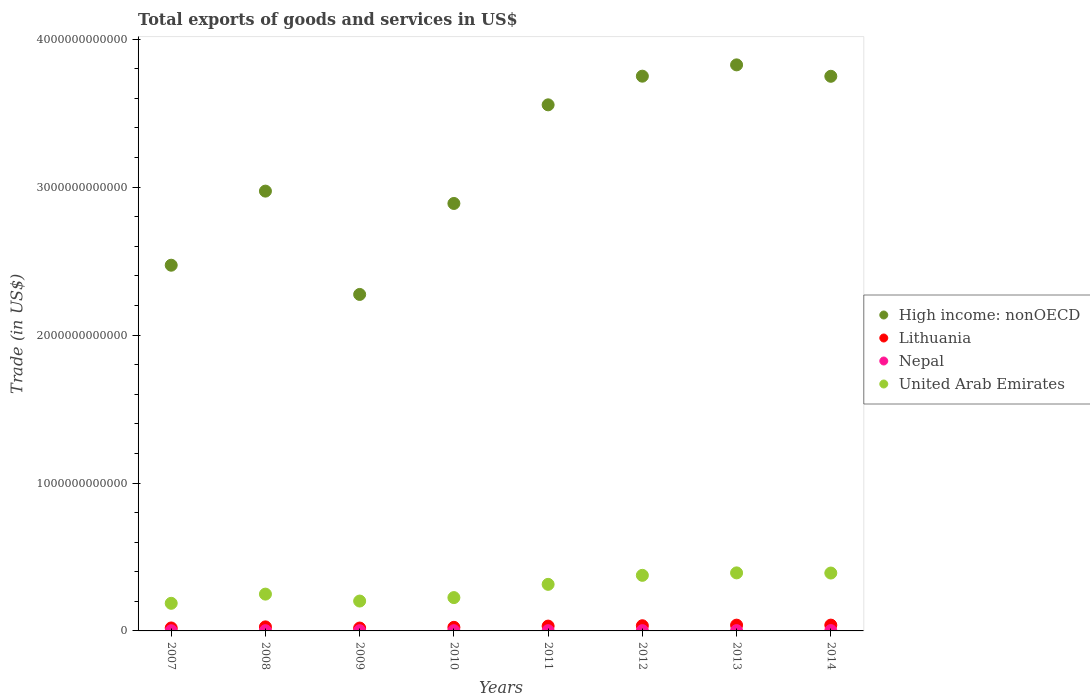How many different coloured dotlines are there?
Your answer should be compact. 4. Is the number of dotlines equal to the number of legend labels?
Your response must be concise. Yes. What is the total exports of goods and services in Lithuania in 2014?
Make the answer very short. 3.93e+1. Across all years, what is the maximum total exports of goods and services in Lithuania?
Make the answer very short. 3.93e+1. Across all years, what is the minimum total exports of goods and services in Nepal?
Offer a very short reply. 1.33e+09. In which year was the total exports of goods and services in Nepal maximum?
Offer a terse response. 2014. What is the total total exports of goods and services in Lithuania in the graph?
Ensure brevity in your answer.  2.37e+11. What is the difference between the total exports of goods and services in High income: nonOECD in 2007 and that in 2010?
Your answer should be very brief. -4.17e+11. What is the difference between the total exports of goods and services in United Arab Emirates in 2014 and the total exports of goods and services in Nepal in 2007?
Offer a terse response. 3.90e+11. What is the average total exports of goods and services in High income: nonOECD per year?
Give a very brief answer. 3.19e+12. In the year 2009, what is the difference between the total exports of goods and services in High income: nonOECD and total exports of goods and services in Nepal?
Provide a succinct answer. 2.27e+12. In how many years, is the total exports of goods and services in United Arab Emirates greater than 800000000000 US$?
Provide a short and direct response. 0. What is the ratio of the total exports of goods and services in Nepal in 2008 to that in 2009?
Your answer should be very brief. 1. What is the difference between the highest and the second highest total exports of goods and services in Lithuania?
Ensure brevity in your answer.  2.60e+08. What is the difference between the highest and the lowest total exports of goods and services in High income: nonOECD?
Offer a very short reply. 1.55e+12. In how many years, is the total exports of goods and services in Lithuania greater than the average total exports of goods and services in Lithuania taken over all years?
Give a very brief answer. 4. Is it the case that in every year, the sum of the total exports of goods and services in High income: nonOECD and total exports of goods and services in Lithuania  is greater than the sum of total exports of goods and services in Nepal and total exports of goods and services in United Arab Emirates?
Your answer should be very brief. Yes. Is it the case that in every year, the sum of the total exports of goods and services in Lithuania and total exports of goods and services in Nepal  is greater than the total exports of goods and services in High income: nonOECD?
Ensure brevity in your answer.  No. Is the total exports of goods and services in High income: nonOECD strictly less than the total exports of goods and services in United Arab Emirates over the years?
Your answer should be compact. No. How many dotlines are there?
Make the answer very short. 4. What is the difference between two consecutive major ticks on the Y-axis?
Provide a short and direct response. 1.00e+12. Does the graph contain grids?
Provide a succinct answer. No. Where does the legend appear in the graph?
Your answer should be very brief. Center right. What is the title of the graph?
Make the answer very short. Total exports of goods and services in US$. Does "Northern Mariana Islands" appear as one of the legend labels in the graph?
Your response must be concise. No. What is the label or title of the Y-axis?
Your answer should be compact. Trade (in US$). What is the Trade (in US$) in High income: nonOECD in 2007?
Ensure brevity in your answer.  2.47e+12. What is the Trade (in US$) of Lithuania in 2007?
Keep it short and to the point. 2.00e+1. What is the Trade (in US$) of Nepal in 2007?
Your response must be concise. 1.33e+09. What is the Trade (in US$) in United Arab Emirates in 2007?
Offer a very short reply. 1.87e+11. What is the Trade (in US$) in High income: nonOECD in 2008?
Ensure brevity in your answer.  2.97e+12. What is the Trade (in US$) of Lithuania in 2008?
Ensure brevity in your answer.  2.73e+1. What is the Trade (in US$) in Nepal in 2008?
Your answer should be very brief. 1.60e+09. What is the Trade (in US$) in United Arab Emirates in 2008?
Offer a terse response. 2.49e+11. What is the Trade (in US$) of High income: nonOECD in 2009?
Ensure brevity in your answer.  2.27e+12. What is the Trade (in US$) in Lithuania in 2009?
Your answer should be very brief. 1.94e+1. What is the Trade (in US$) of Nepal in 2009?
Provide a succinct answer. 1.60e+09. What is the Trade (in US$) of United Arab Emirates in 2009?
Offer a terse response. 2.02e+11. What is the Trade (in US$) in High income: nonOECD in 2010?
Offer a terse response. 2.89e+12. What is the Trade (in US$) in Lithuania in 2010?
Provide a short and direct response. 2.43e+1. What is the Trade (in US$) of Nepal in 2010?
Your response must be concise. 1.53e+09. What is the Trade (in US$) in United Arab Emirates in 2010?
Provide a succinct answer. 2.25e+11. What is the Trade (in US$) in High income: nonOECD in 2011?
Offer a very short reply. 3.56e+12. What is the Trade (in US$) in Lithuania in 2011?
Make the answer very short. 3.26e+1. What is the Trade (in US$) in Nepal in 2011?
Your answer should be compact. 1.68e+09. What is the Trade (in US$) in United Arab Emirates in 2011?
Your answer should be very brief. 3.15e+11. What is the Trade (in US$) of High income: nonOECD in 2012?
Keep it short and to the point. 3.75e+12. What is the Trade (in US$) of Lithuania in 2012?
Your response must be concise. 3.50e+1. What is the Trade (in US$) of Nepal in 2012?
Give a very brief answer. 1.90e+09. What is the Trade (in US$) in United Arab Emirates in 2012?
Your answer should be compact. 3.76e+11. What is the Trade (in US$) in High income: nonOECD in 2013?
Offer a very short reply. 3.83e+12. What is the Trade (in US$) in Lithuania in 2013?
Your answer should be compact. 3.90e+1. What is the Trade (in US$) in Nepal in 2013?
Ensure brevity in your answer.  2.06e+09. What is the Trade (in US$) in United Arab Emirates in 2013?
Offer a very short reply. 3.92e+11. What is the Trade (in US$) of High income: nonOECD in 2014?
Your response must be concise. 3.75e+12. What is the Trade (in US$) of Lithuania in 2014?
Ensure brevity in your answer.  3.93e+1. What is the Trade (in US$) of Nepal in 2014?
Keep it short and to the point. 2.30e+09. What is the Trade (in US$) of United Arab Emirates in 2014?
Give a very brief answer. 3.91e+11. Across all years, what is the maximum Trade (in US$) of High income: nonOECD?
Your answer should be compact. 3.83e+12. Across all years, what is the maximum Trade (in US$) of Lithuania?
Your response must be concise. 3.93e+1. Across all years, what is the maximum Trade (in US$) of Nepal?
Keep it short and to the point. 2.30e+09. Across all years, what is the maximum Trade (in US$) of United Arab Emirates?
Your response must be concise. 3.92e+11. Across all years, what is the minimum Trade (in US$) of High income: nonOECD?
Provide a succinct answer. 2.27e+12. Across all years, what is the minimum Trade (in US$) in Lithuania?
Provide a short and direct response. 1.94e+1. Across all years, what is the minimum Trade (in US$) in Nepal?
Keep it short and to the point. 1.33e+09. Across all years, what is the minimum Trade (in US$) of United Arab Emirates?
Provide a short and direct response. 1.87e+11. What is the total Trade (in US$) of High income: nonOECD in the graph?
Provide a succinct answer. 2.55e+13. What is the total Trade (in US$) in Lithuania in the graph?
Your answer should be compact. 2.37e+11. What is the total Trade (in US$) of Nepal in the graph?
Offer a very short reply. 1.40e+1. What is the total Trade (in US$) in United Arab Emirates in the graph?
Your response must be concise. 2.34e+12. What is the difference between the Trade (in US$) of High income: nonOECD in 2007 and that in 2008?
Provide a short and direct response. -5.01e+11. What is the difference between the Trade (in US$) in Lithuania in 2007 and that in 2008?
Keep it short and to the point. -7.31e+09. What is the difference between the Trade (in US$) in Nepal in 2007 and that in 2008?
Provide a short and direct response. -2.75e+08. What is the difference between the Trade (in US$) of United Arab Emirates in 2007 and that in 2008?
Your answer should be compact. -6.21e+1. What is the difference between the Trade (in US$) of High income: nonOECD in 2007 and that in 2009?
Your answer should be compact. 1.98e+11. What is the difference between the Trade (in US$) of Lithuania in 2007 and that in 2009?
Offer a terse response. 5.89e+08. What is the difference between the Trade (in US$) in Nepal in 2007 and that in 2009?
Provide a succinct answer. -2.69e+08. What is the difference between the Trade (in US$) in United Arab Emirates in 2007 and that in 2009?
Ensure brevity in your answer.  -1.53e+1. What is the difference between the Trade (in US$) in High income: nonOECD in 2007 and that in 2010?
Make the answer very short. -4.17e+11. What is the difference between the Trade (in US$) of Lithuania in 2007 and that in 2010?
Make the answer very short. -4.23e+09. What is the difference between the Trade (in US$) of Nepal in 2007 and that in 2010?
Offer a very short reply. -2.06e+08. What is the difference between the Trade (in US$) of United Arab Emirates in 2007 and that in 2010?
Your response must be concise. -3.86e+1. What is the difference between the Trade (in US$) in High income: nonOECD in 2007 and that in 2011?
Your answer should be compact. -1.08e+12. What is the difference between the Trade (in US$) in Lithuania in 2007 and that in 2011?
Make the answer very short. -1.26e+1. What is the difference between the Trade (in US$) of Nepal in 2007 and that in 2011?
Make the answer very short. -3.57e+08. What is the difference between the Trade (in US$) of United Arab Emirates in 2007 and that in 2011?
Give a very brief answer. -1.28e+11. What is the difference between the Trade (in US$) in High income: nonOECD in 2007 and that in 2012?
Keep it short and to the point. -1.28e+12. What is the difference between the Trade (in US$) of Lithuania in 2007 and that in 2012?
Provide a succinct answer. -1.50e+1. What is the difference between the Trade (in US$) of Nepal in 2007 and that in 2012?
Ensure brevity in your answer.  -5.72e+08. What is the difference between the Trade (in US$) of United Arab Emirates in 2007 and that in 2012?
Keep it short and to the point. -1.89e+11. What is the difference between the Trade (in US$) of High income: nonOECD in 2007 and that in 2013?
Provide a succinct answer. -1.35e+12. What is the difference between the Trade (in US$) of Lithuania in 2007 and that in 2013?
Provide a succinct answer. -1.90e+1. What is the difference between the Trade (in US$) in Nepal in 2007 and that in 2013?
Provide a short and direct response. -7.32e+08. What is the difference between the Trade (in US$) in United Arab Emirates in 2007 and that in 2013?
Offer a terse response. -2.06e+11. What is the difference between the Trade (in US$) in High income: nonOECD in 2007 and that in 2014?
Provide a succinct answer. -1.28e+12. What is the difference between the Trade (in US$) of Lithuania in 2007 and that in 2014?
Offer a very short reply. -1.92e+1. What is the difference between the Trade (in US$) in Nepal in 2007 and that in 2014?
Offer a very short reply. -9.74e+08. What is the difference between the Trade (in US$) in United Arab Emirates in 2007 and that in 2014?
Provide a short and direct response. -2.05e+11. What is the difference between the Trade (in US$) in High income: nonOECD in 2008 and that in 2009?
Offer a very short reply. 6.98e+11. What is the difference between the Trade (in US$) in Lithuania in 2008 and that in 2009?
Your answer should be compact. 7.89e+09. What is the difference between the Trade (in US$) in Nepal in 2008 and that in 2009?
Keep it short and to the point. 6.28e+06. What is the difference between the Trade (in US$) in United Arab Emirates in 2008 and that in 2009?
Ensure brevity in your answer.  4.68e+1. What is the difference between the Trade (in US$) in High income: nonOECD in 2008 and that in 2010?
Offer a terse response. 8.34e+1. What is the difference between the Trade (in US$) in Lithuania in 2008 and that in 2010?
Provide a short and direct response. 3.08e+09. What is the difference between the Trade (in US$) in Nepal in 2008 and that in 2010?
Make the answer very short. 6.93e+07. What is the difference between the Trade (in US$) in United Arab Emirates in 2008 and that in 2010?
Keep it short and to the point. 2.35e+1. What is the difference between the Trade (in US$) in High income: nonOECD in 2008 and that in 2011?
Provide a succinct answer. -5.83e+11. What is the difference between the Trade (in US$) of Lithuania in 2008 and that in 2011?
Offer a very short reply. -5.30e+09. What is the difference between the Trade (in US$) in Nepal in 2008 and that in 2011?
Your response must be concise. -8.13e+07. What is the difference between the Trade (in US$) in United Arab Emirates in 2008 and that in 2011?
Give a very brief answer. -6.60e+1. What is the difference between the Trade (in US$) in High income: nonOECD in 2008 and that in 2012?
Ensure brevity in your answer.  -7.77e+11. What is the difference between the Trade (in US$) of Lithuania in 2008 and that in 2012?
Your answer should be very brief. -7.65e+09. What is the difference between the Trade (in US$) of Nepal in 2008 and that in 2012?
Your answer should be compact. -2.96e+08. What is the difference between the Trade (in US$) of United Arab Emirates in 2008 and that in 2012?
Your answer should be very brief. -1.27e+11. What is the difference between the Trade (in US$) in High income: nonOECD in 2008 and that in 2013?
Your answer should be very brief. -8.54e+11. What is the difference between the Trade (in US$) of Lithuania in 2008 and that in 2013?
Offer a very short reply. -1.17e+1. What is the difference between the Trade (in US$) in Nepal in 2008 and that in 2013?
Your answer should be very brief. -4.57e+08. What is the difference between the Trade (in US$) in United Arab Emirates in 2008 and that in 2013?
Provide a short and direct response. -1.44e+11. What is the difference between the Trade (in US$) in High income: nonOECD in 2008 and that in 2014?
Make the answer very short. -7.76e+11. What is the difference between the Trade (in US$) of Lithuania in 2008 and that in 2014?
Ensure brevity in your answer.  -1.19e+1. What is the difference between the Trade (in US$) in Nepal in 2008 and that in 2014?
Your response must be concise. -6.99e+08. What is the difference between the Trade (in US$) of United Arab Emirates in 2008 and that in 2014?
Provide a succinct answer. -1.42e+11. What is the difference between the Trade (in US$) of High income: nonOECD in 2009 and that in 2010?
Make the answer very short. -6.15e+11. What is the difference between the Trade (in US$) of Lithuania in 2009 and that in 2010?
Your response must be concise. -4.82e+09. What is the difference between the Trade (in US$) in Nepal in 2009 and that in 2010?
Provide a short and direct response. 6.30e+07. What is the difference between the Trade (in US$) of United Arab Emirates in 2009 and that in 2010?
Ensure brevity in your answer.  -2.33e+1. What is the difference between the Trade (in US$) in High income: nonOECD in 2009 and that in 2011?
Provide a succinct answer. -1.28e+12. What is the difference between the Trade (in US$) of Lithuania in 2009 and that in 2011?
Provide a succinct answer. -1.32e+1. What is the difference between the Trade (in US$) in Nepal in 2009 and that in 2011?
Ensure brevity in your answer.  -8.76e+07. What is the difference between the Trade (in US$) of United Arab Emirates in 2009 and that in 2011?
Give a very brief answer. -1.13e+11. What is the difference between the Trade (in US$) in High income: nonOECD in 2009 and that in 2012?
Provide a short and direct response. -1.48e+12. What is the difference between the Trade (in US$) in Lithuania in 2009 and that in 2012?
Provide a short and direct response. -1.55e+1. What is the difference between the Trade (in US$) of Nepal in 2009 and that in 2012?
Offer a very short reply. -3.03e+08. What is the difference between the Trade (in US$) of United Arab Emirates in 2009 and that in 2012?
Offer a terse response. -1.74e+11. What is the difference between the Trade (in US$) of High income: nonOECD in 2009 and that in 2013?
Offer a terse response. -1.55e+12. What is the difference between the Trade (in US$) in Lithuania in 2009 and that in 2013?
Ensure brevity in your answer.  -1.96e+1. What is the difference between the Trade (in US$) of Nepal in 2009 and that in 2013?
Give a very brief answer. -4.63e+08. What is the difference between the Trade (in US$) of United Arab Emirates in 2009 and that in 2013?
Make the answer very short. -1.90e+11. What is the difference between the Trade (in US$) of High income: nonOECD in 2009 and that in 2014?
Keep it short and to the point. -1.47e+12. What is the difference between the Trade (in US$) in Lithuania in 2009 and that in 2014?
Make the answer very short. -1.98e+1. What is the difference between the Trade (in US$) in Nepal in 2009 and that in 2014?
Your answer should be compact. -7.05e+08. What is the difference between the Trade (in US$) of United Arab Emirates in 2009 and that in 2014?
Provide a succinct answer. -1.89e+11. What is the difference between the Trade (in US$) of High income: nonOECD in 2010 and that in 2011?
Your answer should be very brief. -6.67e+11. What is the difference between the Trade (in US$) in Lithuania in 2010 and that in 2011?
Your response must be concise. -8.38e+09. What is the difference between the Trade (in US$) in Nepal in 2010 and that in 2011?
Your answer should be compact. -1.51e+08. What is the difference between the Trade (in US$) in United Arab Emirates in 2010 and that in 2011?
Make the answer very short. -8.96e+1. What is the difference between the Trade (in US$) in High income: nonOECD in 2010 and that in 2012?
Make the answer very short. -8.61e+11. What is the difference between the Trade (in US$) of Lithuania in 2010 and that in 2012?
Keep it short and to the point. -1.07e+1. What is the difference between the Trade (in US$) in Nepal in 2010 and that in 2012?
Make the answer very short. -3.66e+08. What is the difference between the Trade (in US$) of United Arab Emirates in 2010 and that in 2012?
Your answer should be very brief. -1.51e+11. What is the difference between the Trade (in US$) of High income: nonOECD in 2010 and that in 2013?
Your response must be concise. -9.37e+11. What is the difference between the Trade (in US$) of Lithuania in 2010 and that in 2013?
Ensure brevity in your answer.  -1.47e+1. What is the difference between the Trade (in US$) of Nepal in 2010 and that in 2013?
Your answer should be very brief. -5.26e+08. What is the difference between the Trade (in US$) of United Arab Emirates in 2010 and that in 2013?
Your answer should be very brief. -1.67e+11. What is the difference between the Trade (in US$) of High income: nonOECD in 2010 and that in 2014?
Your response must be concise. -8.60e+11. What is the difference between the Trade (in US$) in Lithuania in 2010 and that in 2014?
Offer a terse response. -1.50e+1. What is the difference between the Trade (in US$) in Nepal in 2010 and that in 2014?
Provide a succinct answer. -7.68e+08. What is the difference between the Trade (in US$) of United Arab Emirates in 2010 and that in 2014?
Your answer should be compact. -1.66e+11. What is the difference between the Trade (in US$) of High income: nonOECD in 2011 and that in 2012?
Offer a very short reply. -1.94e+11. What is the difference between the Trade (in US$) in Lithuania in 2011 and that in 2012?
Ensure brevity in your answer.  -2.35e+09. What is the difference between the Trade (in US$) in Nepal in 2011 and that in 2012?
Your answer should be very brief. -2.15e+08. What is the difference between the Trade (in US$) in United Arab Emirates in 2011 and that in 2012?
Offer a very short reply. -6.10e+1. What is the difference between the Trade (in US$) in High income: nonOECD in 2011 and that in 2013?
Offer a very short reply. -2.70e+11. What is the difference between the Trade (in US$) of Lithuania in 2011 and that in 2013?
Your answer should be very brief. -6.37e+09. What is the difference between the Trade (in US$) in Nepal in 2011 and that in 2013?
Your answer should be compact. -3.76e+08. What is the difference between the Trade (in US$) in United Arab Emirates in 2011 and that in 2013?
Offer a terse response. -7.75e+1. What is the difference between the Trade (in US$) in High income: nonOECD in 2011 and that in 2014?
Provide a short and direct response. -1.93e+11. What is the difference between the Trade (in US$) of Lithuania in 2011 and that in 2014?
Ensure brevity in your answer.  -6.63e+09. What is the difference between the Trade (in US$) in Nepal in 2011 and that in 2014?
Ensure brevity in your answer.  -6.17e+08. What is the difference between the Trade (in US$) in United Arab Emirates in 2011 and that in 2014?
Provide a short and direct response. -7.65e+1. What is the difference between the Trade (in US$) in High income: nonOECD in 2012 and that in 2013?
Provide a short and direct response. -7.64e+1. What is the difference between the Trade (in US$) in Lithuania in 2012 and that in 2013?
Your response must be concise. -4.02e+09. What is the difference between the Trade (in US$) of Nepal in 2012 and that in 2013?
Your answer should be very brief. -1.61e+08. What is the difference between the Trade (in US$) in United Arab Emirates in 2012 and that in 2013?
Your answer should be very brief. -1.66e+1. What is the difference between the Trade (in US$) of High income: nonOECD in 2012 and that in 2014?
Keep it short and to the point. 7.85e+08. What is the difference between the Trade (in US$) in Lithuania in 2012 and that in 2014?
Ensure brevity in your answer.  -4.28e+09. What is the difference between the Trade (in US$) in Nepal in 2012 and that in 2014?
Keep it short and to the point. -4.02e+08. What is the difference between the Trade (in US$) of United Arab Emirates in 2012 and that in 2014?
Offer a very short reply. -1.55e+1. What is the difference between the Trade (in US$) in High income: nonOECD in 2013 and that in 2014?
Offer a terse response. 7.72e+1. What is the difference between the Trade (in US$) of Lithuania in 2013 and that in 2014?
Give a very brief answer. -2.60e+08. What is the difference between the Trade (in US$) in Nepal in 2013 and that in 2014?
Offer a terse response. -2.41e+08. What is the difference between the Trade (in US$) of United Arab Emirates in 2013 and that in 2014?
Your answer should be very brief. 1.09e+09. What is the difference between the Trade (in US$) of High income: nonOECD in 2007 and the Trade (in US$) of Lithuania in 2008?
Keep it short and to the point. 2.45e+12. What is the difference between the Trade (in US$) in High income: nonOECD in 2007 and the Trade (in US$) in Nepal in 2008?
Your response must be concise. 2.47e+12. What is the difference between the Trade (in US$) in High income: nonOECD in 2007 and the Trade (in US$) in United Arab Emirates in 2008?
Ensure brevity in your answer.  2.22e+12. What is the difference between the Trade (in US$) of Lithuania in 2007 and the Trade (in US$) of Nepal in 2008?
Your response must be concise. 1.84e+1. What is the difference between the Trade (in US$) of Lithuania in 2007 and the Trade (in US$) of United Arab Emirates in 2008?
Offer a terse response. -2.29e+11. What is the difference between the Trade (in US$) of Nepal in 2007 and the Trade (in US$) of United Arab Emirates in 2008?
Provide a short and direct response. -2.47e+11. What is the difference between the Trade (in US$) of High income: nonOECD in 2007 and the Trade (in US$) of Lithuania in 2009?
Ensure brevity in your answer.  2.45e+12. What is the difference between the Trade (in US$) in High income: nonOECD in 2007 and the Trade (in US$) in Nepal in 2009?
Keep it short and to the point. 2.47e+12. What is the difference between the Trade (in US$) of High income: nonOECD in 2007 and the Trade (in US$) of United Arab Emirates in 2009?
Offer a terse response. 2.27e+12. What is the difference between the Trade (in US$) of Lithuania in 2007 and the Trade (in US$) of Nepal in 2009?
Keep it short and to the point. 1.84e+1. What is the difference between the Trade (in US$) of Lithuania in 2007 and the Trade (in US$) of United Arab Emirates in 2009?
Make the answer very short. -1.82e+11. What is the difference between the Trade (in US$) of Nepal in 2007 and the Trade (in US$) of United Arab Emirates in 2009?
Your answer should be very brief. -2.01e+11. What is the difference between the Trade (in US$) in High income: nonOECD in 2007 and the Trade (in US$) in Lithuania in 2010?
Give a very brief answer. 2.45e+12. What is the difference between the Trade (in US$) of High income: nonOECD in 2007 and the Trade (in US$) of Nepal in 2010?
Offer a very short reply. 2.47e+12. What is the difference between the Trade (in US$) of High income: nonOECD in 2007 and the Trade (in US$) of United Arab Emirates in 2010?
Offer a terse response. 2.25e+12. What is the difference between the Trade (in US$) of Lithuania in 2007 and the Trade (in US$) of Nepal in 2010?
Your response must be concise. 1.85e+1. What is the difference between the Trade (in US$) of Lithuania in 2007 and the Trade (in US$) of United Arab Emirates in 2010?
Keep it short and to the point. -2.05e+11. What is the difference between the Trade (in US$) of Nepal in 2007 and the Trade (in US$) of United Arab Emirates in 2010?
Your response must be concise. -2.24e+11. What is the difference between the Trade (in US$) in High income: nonOECD in 2007 and the Trade (in US$) in Lithuania in 2011?
Your answer should be compact. 2.44e+12. What is the difference between the Trade (in US$) in High income: nonOECD in 2007 and the Trade (in US$) in Nepal in 2011?
Make the answer very short. 2.47e+12. What is the difference between the Trade (in US$) in High income: nonOECD in 2007 and the Trade (in US$) in United Arab Emirates in 2011?
Give a very brief answer. 2.16e+12. What is the difference between the Trade (in US$) of Lithuania in 2007 and the Trade (in US$) of Nepal in 2011?
Provide a short and direct response. 1.84e+1. What is the difference between the Trade (in US$) in Lithuania in 2007 and the Trade (in US$) in United Arab Emirates in 2011?
Give a very brief answer. -2.95e+11. What is the difference between the Trade (in US$) of Nepal in 2007 and the Trade (in US$) of United Arab Emirates in 2011?
Offer a terse response. -3.14e+11. What is the difference between the Trade (in US$) in High income: nonOECD in 2007 and the Trade (in US$) in Lithuania in 2012?
Your answer should be very brief. 2.44e+12. What is the difference between the Trade (in US$) of High income: nonOECD in 2007 and the Trade (in US$) of Nepal in 2012?
Your answer should be compact. 2.47e+12. What is the difference between the Trade (in US$) in High income: nonOECD in 2007 and the Trade (in US$) in United Arab Emirates in 2012?
Your answer should be very brief. 2.10e+12. What is the difference between the Trade (in US$) in Lithuania in 2007 and the Trade (in US$) in Nepal in 2012?
Keep it short and to the point. 1.81e+1. What is the difference between the Trade (in US$) in Lithuania in 2007 and the Trade (in US$) in United Arab Emirates in 2012?
Ensure brevity in your answer.  -3.56e+11. What is the difference between the Trade (in US$) in Nepal in 2007 and the Trade (in US$) in United Arab Emirates in 2012?
Ensure brevity in your answer.  -3.74e+11. What is the difference between the Trade (in US$) in High income: nonOECD in 2007 and the Trade (in US$) in Lithuania in 2013?
Make the answer very short. 2.43e+12. What is the difference between the Trade (in US$) in High income: nonOECD in 2007 and the Trade (in US$) in Nepal in 2013?
Provide a succinct answer. 2.47e+12. What is the difference between the Trade (in US$) in High income: nonOECD in 2007 and the Trade (in US$) in United Arab Emirates in 2013?
Offer a very short reply. 2.08e+12. What is the difference between the Trade (in US$) of Lithuania in 2007 and the Trade (in US$) of Nepal in 2013?
Offer a terse response. 1.80e+1. What is the difference between the Trade (in US$) of Lithuania in 2007 and the Trade (in US$) of United Arab Emirates in 2013?
Offer a very short reply. -3.72e+11. What is the difference between the Trade (in US$) of Nepal in 2007 and the Trade (in US$) of United Arab Emirates in 2013?
Give a very brief answer. -3.91e+11. What is the difference between the Trade (in US$) in High income: nonOECD in 2007 and the Trade (in US$) in Lithuania in 2014?
Your response must be concise. 2.43e+12. What is the difference between the Trade (in US$) in High income: nonOECD in 2007 and the Trade (in US$) in Nepal in 2014?
Ensure brevity in your answer.  2.47e+12. What is the difference between the Trade (in US$) of High income: nonOECD in 2007 and the Trade (in US$) of United Arab Emirates in 2014?
Your response must be concise. 2.08e+12. What is the difference between the Trade (in US$) of Lithuania in 2007 and the Trade (in US$) of Nepal in 2014?
Your answer should be compact. 1.77e+1. What is the difference between the Trade (in US$) of Lithuania in 2007 and the Trade (in US$) of United Arab Emirates in 2014?
Provide a short and direct response. -3.71e+11. What is the difference between the Trade (in US$) in Nepal in 2007 and the Trade (in US$) in United Arab Emirates in 2014?
Offer a terse response. -3.90e+11. What is the difference between the Trade (in US$) of High income: nonOECD in 2008 and the Trade (in US$) of Lithuania in 2009?
Offer a terse response. 2.95e+12. What is the difference between the Trade (in US$) of High income: nonOECD in 2008 and the Trade (in US$) of Nepal in 2009?
Your answer should be very brief. 2.97e+12. What is the difference between the Trade (in US$) of High income: nonOECD in 2008 and the Trade (in US$) of United Arab Emirates in 2009?
Your answer should be compact. 2.77e+12. What is the difference between the Trade (in US$) in Lithuania in 2008 and the Trade (in US$) in Nepal in 2009?
Provide a succinct answer. 2.57e+1. What is the difference between the Trade (in US$) of Lithuania in 2008 and the Trade (in US$) of United Arab Emirates in 2009?
Your response must be concise. -1.75e+11. What is the difference between the Trade (in US$) in Nepal in 2008 and the Trade (in US$) in United Arab Emirates in 2009?
Your answer should be compact. -2.00e+11. What is the difference between the Trade (in US$) of High income: nonOECD in 2008 and the Trade (in US$) of Lithuania in 2010?
Your answer should be very brief. 2.95e+12. What is the difference between the Trade (in US$) in High income: nonOECD in 2008 and the Trade (in US$) in Nepal in 2010?
Your answer should be compact. 2.97e+12. What is the difference between the Trade (in US$) in High income: nonOECD in 2008 and the Trade (in US$) in United Arab Emirates in 2010?
Your response must be concise. 2.75e+12. What is the difference between the Trade (in US$) in Lithuania in 2008 and the Trade (in US$) in Nepal in 2010?
Your response must be concise. 2.58e+1. What is the difference between the Trade (in US$) in Lithuania in 2008 and the Trade (in US$) in United Arab Emirates in 2010?
Offer a terse response. -1.98e+11. What is the difference between the Trade (in US$) in Nepal in 2008 and the Trade (in US$) in United Arab Emirates in 2010?
Offer a terse response. -2.24e+11. What is the difference between the Trade (in US$) of High income: nonOECD in 2008 and the Trade (in US$) of Lithuania in 2011?
Offer a terse response. 2.94e+12. What is the difference between the Trade (in US$) of High income: nonOECD in 2008 and the Trade (in US$) of Nepal in 2011?
Your answer should be very brief. 2.97e+12. What is the difference between the Trade (in US$) of High income: nonOECD in 2008 and the Trade (in US$) of United Arab Emirates in 2011?
Your answer should be very brief. 2.66e+12. What is the difference between the Trade (in US$) in Lithuania in 2008 and the Trade (in US$) in Nepal in 2011?
Give a very brief answer. 2.57e+1. What is the difference between the Trade (in US$) of Lithuania in 2008 and the Trade (in US$) of United Arab Emirates in 2011?
Provide a succinct answer. -2.87e+11. What is the difference between the Trade (in US$) in Nepal in 2008 and the Trade (in US$) in United Arab Emirates in 2011?
Give a very brief answer. -3.13e+11. What is the difference between the Trade (in US$) in High income: nonOECD in 2008 and the Trade (in US$) in Lithuania in 2012?
Your response must be concise. 2.94e+12. What is the difference between the Trade (in US$) in High income: nonOECD in 2008 and the Trade (in US$) in Nepal in 2012?
Your response must be concise. 2.97e+12. What is the difference between the Trade (in US$) of High income: nonOECD in 2008 and the Trade (in US$) of United Arab Emirates in 2012?
Provide a succinct answer. 2.60e+12. What is the difference between the Trade (in US$) in Lithuania in 2008 and the Trade (in US$) in Nepal in 2012?
Offer a terse response. 2.54e+1. What is the difference between the Trade (in US$) in Lithuania in 2008 and the Trade (in US$) in United Arab Emirates in 2012?
Your answer should be very brief. -3.48e+11. What is the difference between the Trade (in US$) of Nepal in 2008 and the Trade (in US$) of United Arab Emirates in 2012?
Your answer should be very brief. -3.74e+11. What is the difference between the Trade (in US$) of High income: nonOECD in 2008 and the Trade (in US$) of Lithuania in 2013?
Keep it short and to the point. 2.93e+12. What is the difference between the Trade (in US$) in High income: nonOECD in 2008 and the Trade (in US$) in Nepal in 2013?
Offer a very short reply. 2.97e+12. What is the difference between the Trade (in US$) of High income: nonOECD in 2008 and the Trade (in US$) of United Arab Emirates in 2013?
Provide a succinct answer. 2.58e+12. What is the difference between the Trade (in US$) in Lithuania in 2008 and the Trade (in US$) in Nepal in 2013?
Give a very brief answer. 2.53e+1. What is the difference between the Trade (in US$) of Lithuania in 2008 and the Trade (in US$) of United Arab Emirates in 2013?
Ensure brevity in your answer.  -3.65e+11. What is the difference between the Trade (in US$) of Nepal in 2008 and the Trade (in US$) of United Arab Emirates in 2013?
Make the answer very short. -3.91e+11. What is the difference between the Trade (in US$) in High income: nonOECD in 2008 and the Trade (in US$) in Lithuania in 2014?
Offer a terse response. 2.93e+12. What is the difference between the Trade (in US$) of High income: nonOECD in 2008 and the Trade (in US$) of Nepal in 2014?
Give a very brief answer. 2.97e+12. What is the difference between the Trade (in US$) of High income: nonOECD in 2008 and the Trade (in US$) of United Arab Emirates in 2014?
Offer a terse response. 2.58e+12. What is the difference between the Trade (in US$) of Lithuania in 2008 and the Trade (in US$) of Nepal in 2014?
Provide a succinct answer. 2.50e+1. What is the difference between the Trade (in US$) of Lithuania in 2008 and the Trade (in US$) of United Arab Emirates in 2014?
Keep it short and to the point. -3.64e+11. What is the difference between the Trade (in US$) in Nepal in 2008 and the Trade (in US$) in United Arab Emirates in 2014?
Your answer should be very brief. -3.90e+11. What is the difference between the Trade (in US$) in High income: nonOECD in 2009 and the Trade (in US$) in Lithuania in 2010?
Make the answer very short. 2.25e+12. What is the difference between the Trade (in US$) in High income: nonOECD in 2009 and the Trade (in US$) in Nepal in 2010?
Make the answer very short. 2.27e+12. What is the difference between the Trade (in US$) in High income: nonOECD in 2009 and the Trade (in US$) in United Arab Emirates in 2010?
Keep it short and to the point. 2.05e+12. What is the difference between the Trade (in US$) of Lithuania in 2009 and the Trade (in US$) of Nepal in 2010?
Offer a very short reply. 1.79e+1. What is the difference between the Trade (in US$) in Lithuania in 2009 and the Trade (in US$) in United Arab Emirates in 2010?
Your answer should be very brief. -2.06e+11. What is the difference between the Trade (in US$) in Nepal in 2009 and the Trade (in US$) in United Arab Emirates in 2010?
Ensure brevity in your answer.  -2.24e+11. What is the difference between the Trade (in US$) in High income: nonOECD in 2009 and the Trade (in US$) in Lithuania in 2011?
Make the answer very short. 2.24e+12. What is the difference between the Trade (in US$) in High income: nonOECD in 2009 and the Trade (in US$) in Nepal in 2011?
Ensure brevity in your answer.  2.27e+12. What is the difference between the Trade (in US$) of High income: nonOECD in 2009 and the Trade (in US$) of United Arab Emirates in 2011?
Make the answer very short. 1.96e+12. What is the difference between the Trade (in US$) in Lithuania in 2009 and the Trade (in US$) in Nepal in 2011?
Offer a terse response. 1.78e+1. What is the difference between the Trade (in US$) in Lithuania in 2009 and the Trade (in US$) in United Arab Emirates in 2011?
Your response must be concise. -2.95e+11. What is the difference between the Trade (in US$) in Nepal in 2009 and the Trade (in US$) in United Arab Emirates in 2011?
Your answer should be compact. -3.13e+11. What is the difference between the Trade (in US$) in High income: nonOECD in 2009 and the Trade (in US$) in Lithuania in 2012?
Your answer should be very brief. 2.24e+12. What is the difference between the Trade (in US$) in High income: nonOECD in 2009 and the Trade (in US$) in Nepal in 2012?
Provide a succinct answer. 2.27e+12. What is the difference between the Trade (in US$) of High income: nonOECD in 2009 and the Trade (in US$) of United Arab Emirates in 2012?
Keep it short and to the point. 1.90e+12. What is the difference between the Trade (in US$) of Lithuania in 2009 and the Trade (in US$) of Nepal in 2012?
Your answer should be very brief. 1.75e+1. What is the difference between the Trade (in US$) of Lithuania in 2009 and the Trade (in US$) of United Arab Emirates in 2012?
Provide a short and direct response. -3.56e+11. What is the difference between the Trade (in US$) of Nepal in 2009 and the Trade (in US$) of United Arab Emirates in 2012?
Ensure brevity in your answer.  -3.74e+11. What is the difference between the Trade (in US$) in High income: nonOECD in 2009 and the Trade (in US$) in Lithuania in 2013?
Keep it short and to the point. 2.24e+12. What is the difference between the Trade (in US$) in High income: nonOECD in 2009 and the Trade (in US$) in Nepal in 2013?
Your answer should be compact. 2.27e+12. What is the difference between the Trade (in US$) in High income: nonOECD in 2009 and the Trade (in US$) in United Arab Emirates in 2013?
Offer a very short reply. 1.88e+12. What is the difference between the Trade (in US$) of Lithuania in 2009 and the Trade (in US$) of Nepal in 2013?
Keep it short and to the point. 1.74e+1. What is the difference between the Trade (in US$) of Lithuania in 2009 and the Trade (in US$) of United Arab Emirates in 2013?
Offer a terse response. -3.73e+11. What is the difference between the Trade (in US$) of Nepal in 2009 and the Trade (in US$) of United Arab Emirates in 2013?
Provide a short and direct response. -3.91e+11. What is the difference between the Trade (in US$) of High income: nonOECD in 2009 and the Trade (in US$) of Lithuania in 2014?
Your answer should be very brief. 2.24e+12. What is the difference between the Trade (in US$) of High income: nonOECD in 2009 and the Trade (in US$) of Nepal in 2014?
Your answer should be very brief. 2.27e+12. What is the difference between the Trade (in US$) in High income: nonOECD in 2009 and the Trade (in US$) in United Arab Emirates in 2014?
Give a very brief answer. 1.88e+12. What is the difference between the Trade (in US$) of Lithuania in 2009 and the Trade (in US$) of Nepal in 2014?
Your answer should be compact. 1.71e+1. What is the difference between the Trade (in US$) in Lithuania in 2009 and the Trade (in US$) in United Arab Emirates in 2014?
Keep it short and to the point. -3.72e+11. What is the difference between the Trade (in US$) of Nepal in 2009 and the Trade (in US$) of United Arab Emirates in 2014?
Provide a succinct answer. -3.90e+11. What is the difference between the Trade (in US$) of High income: nonOECD in 2010 and the Trade (in US$) of Lithuania in 2011?
Your answer should be very brief. 2.86e+12. What is the difference between the Trade (in US$) in High income: nonOECD in 2010 and the Trade (in US$) in Nepal in 2011?
Your answer should be compact. 2.89e+12. What is the difference between the Trade (in US$) of High income: nonOECD in 2010 and the Trade (in US$) of United Arab Emirates in 2011?
Your answer should be very brief. 2.58e+12. What is the difference between the Trade (in US$) in Lithuania in 2010 and the Trade (in US$) in Nepal in 2011?
Ensure brevity in your answer.  2.26e+1. What is the difference between the Trade (in US$) in Lithuania in 2010 and the Trade (in US$) in United Arab Emirates in 2011?
Offer a very short reply. -2.91e+11. What is the difference between the Trade (in US$) in Nepal in 2010 and the Trade (in US$) in United Arab Emirates in 2011?
Make the answer very short. -3.13e+11. What is the difference between the Trade (in US$) in High income: nonOECD in 2010 and the Trade (in US$) in Lithuania in 2012?
Give a very brief answer. 2.85e+12. What is the difference between the Trade (in US$) in High income: nonOECD in 2010 and the Trade (in US$) in Nepal in 2012?
Offer a very short reply. 2.89e+12. What is the difference between the Trade (in US$) of High income: nonOECD in 2010 and the Trade (in US$) of United Arab Emirates in 2012?
Give a very brief answer. 2.51e+12. What is the difference between the Trade (in US$) in Lithuania in 2010 and the Trade (in US$) in Nepal in 2012?
Offer a terse response. 2.24e+1. What is the difference between the Trade (in US$) of Lithuania in 2010 and the Trade (in US$) of United Arab Emirates in 2012?
Give a very brief answer. -3.52e+11. What is the difference between the Trade (in US$) of Nepal in 2010 and the Trade (in US$) of United Arab Emirates in 2012?
Your answer should be compact. -3.74e+11. What is the difference between the Trade (in US$) of High income: nonOECD in 2010 and the Trade (in US$) of Lithuania in 2013?
Provide a short and direct response. 2.85e+12. What is the difference between the Trade (in US$) of High income: nonOECD in 2010 and the Trade (in US$) of Nepal in 2013?
Keep it short and to the point. 2.89e+12. What is the difference between the Trade (in US$) of High income: nonOECD in 2010 and the Trade (in US$) of United Arab Emirates in 2013?
Keep it short and to the point. 2.50e+12. What is the difference between the Trade (in US$) of Lithuania in 2010 and the Trade (in US$) of Nepal in 2013?
Offer a very short reply. 2.22e+1. What is the difference between the Trade (in US$) of Lithuania in 2010 and the Trade (in US$) of United Arab Emirates in 2013?
Give a very brief answer. -3.68e+11. What is the difference between the Trade (in US$) of Nepal in 2010 and the Trade (in US$) of United Arab Emirates in 2013?
Offer a very short reply. -3.91e+11. What is the difference between the Trade (in US$) of High income: nonOECD in 2010 and the Trade (in US$) of Lithuania in 2014?
Give a very brief answer. 2.85e+12. What is the difference between the Trade (in US$) in High income: nonOECD in 2010 and the Trade (in US$) in Nepal in 2014?
Offer a terse response. 2.89e+12. What is the difference between the Trade (in US$) in High income: nonOECD in 2010 and the Trade (in US$) in United Arab Emirates in 2014?
Give a very brief answer. 2.50e+12. What is the difference between the Trade (in US$) in Lithuania in 2010 and the Trade (in US$) in Nepal in 2014?
Give a very brief answer. 2.20e+1. What is the difference between the Trade (in US$) of Lithuania in 2010 and the Trade (in US$) of United Arab Emirates in 2014?
Ensure brevity in your answer.  -3.67e+11. What is the difference between the Trade (in US$) in Nepal in 2010 and the Trade (in US$) in United Arab Emirates in 2014?
Provide a short and direct response. -3.90e+11. What is the difference between the Trade (in US$) in High income: nonOECD in 2011 and the Trade (in US$) in Lithuania in 2012?
Give a very brief answer. 3.52e+12. What is the difference between the Trade (in US$) in High income: nonOECD in 2011 and the Trade (in US$) in Nepal in 2012?
Your answer should be very brief. 3.55e+12. What is the difference between the Trade (in US$) of High income: nonOECD in 2011 and the Trade (in US$) of United Arab Emirates in 2012?
Make the answer very short. 3.18e+12. What is the difference between the Trade (in US$) of Lithuania in 2011 and the Trade (in US$) of Nepal in 2012?
Make the answer very short. 3.07e+1. What is the difference between the Trade (in US$) in Lithuania in 2011 and the Trade (in US$) in United Arab Emirates in 2012?
Make the answer very short. -3.43e+11. What is the difference between the Trade (in US$) of Nepal in 2011 and the Trade (in US$) of United Arab Emirates in 2012?
Your answer should be very brief. -3.74e+11. What is the difference between the Trade (in US$) of High income: nonOECD in 2011 and the Trade (in US$) of Lithuania in 2013?
Give a very brief answer. 3.52e+12. What is the difference between the Trade (in US$) of High income: nonOECD in 2011 and the Trade (in US$) of Nepal in 2013?
Provide a succinct answer. 3.55e+12. What is the difference between the Trade (in US$) of High income: nonOECD in 2011 and the Trade (in US$) of United Arab Emirates in 2013?
Provide a succinct answer. 3.16e+12. What is the difference between the Trade (in US$) in Lithuania in 2011 and the Trade (in US$) in Nepal in 2013?
Make the answer very short. 3.06e+1. What is the difference between the Trade (in US$) of Lithuania in 2011 and the Trade (in US$) of United Arab Emirates in 2013?
Provide a short and direct response. -3.60e+11. What is the difference between the Trade (in US$) in Nepal in 2011 and the Trade (in US$) in United Arab Emirates in 2013?
Provide a short and direct response. -3.91e+11. What is the difference between the Trade (in US$) in High income: nonOECD in 2011 and the Trade (in US$) in Lithuania in 2014?
Offer a very short reply. 3.52e+12. What is the difference between the Trade (in US$) of High income: nonOECD in 2011 and the Trade (in US$) of Nepal in 2014?
Make the answer very short. 3.55e+12. What is the difference between the Trade (in US$) in High income: nonOECD in 2011 and the Trade (in US$) in United Arab Emirates in 2014?
Your answer should be very brief. 3.17e+12. What is the difference between the Trade (in US$) in Lithuania in 2011 and the Trade (in US$) in Nepal in 2014?
Offer a very short reply. 3.03e+1. What is the difference between the Trade (in US$) of Lithuania in 2011 and the Trade (in US$) of United Arab Emirates in 2014?
Keep it short and to the point. -3.59e+11. What is the difference between the Trade (in US$) in Nepal in 2011 and the Trade (in US$) in United Arab Emirates in 2014?
Make the answer very short. -3.90e+11. What is the difference between the Trade (in US$) in High income: nonOECD in 2012 and the Trade (in US$) in Lithuania in 2013?
Provide a short and direct response. 3.71e+12. What is the difference between the Trade (in US$) in High income: nonOECD in 2012 and the Trade (in US$) in Nepal in 2013?
Your answer should be compact. 3.75e+12. What is the difference between the Trade (in US$) of High income: nonOECD in 2012 and the Trade (in US$) of United Arab Emirates in 2013?
Your answer should be very brief. 3.36e+12. What is the difference between the Trade (in US$) of Lithuania in 2012 and the Trade (in US$) of Nepal in 2013?
Ensure brevity in your answer.  3.29e+1. What is the difference between the Trade (in US$) in Lithuania in 2012 and the Trade (in US$) in United Arab Emirates in 2013?
Make the answer very short. -3.57e+11. What is the difference between the Trade (in US$) in Nepal in 2012 and the Trade (in US$) in United Arab Emirates in 2013?
Give a very brief answer. -3.90e+11. What is the difference between the Trade (in US$) of High income: nonOECD in 2012 and the Trade (in US$) of Lithuania in 2014?
Your response must be concise. 3.71e+12. What is the difference between the Trade (in US$) of High income: nonOECD in 2012 and the Trade (in US$) of Nepal in 2014?
Keep it short and to the point. 3.75e+12. What is the difference between the Trade (in US$) of High income: nonOECD in 2012 and the Trade (in US$) of United Arab Emirates in 2014?
Make the answer very short. 3.36e+12. What is the difference between the Trade (in US$) of Lithuania in 2012 and the Trade (in US$) of Nepal in 2014?
Make the answer very short. 3.27e+1. What is the difference between the Trade (in US$) of Lithuania in 2012 and the Trade (in US$) of United Arab Emirates in 2014?
Ensure brevity in your answer.  -3.56e+11. What is the difference between the Trade (in US$) of Nepal in 2012 and the Trade (in US$) of United Arab Emirates in 2014?
Ensure brevity in your answer.  -3.89e+11. What is the difference between the Trade (in US$) in High income: nonOECD in 2013 and the Trade (in US$) in Lithuania in 2014?
Offer a very short reply. 3.79e+12. What is the difference between the Trade (in US$) in High income: nonOECD in 2013 and the Trade (in US$) in Nepal in 2014?
Offer a terse response. 3.82e+12. What is the difference between the Trade (in US$) in High income: nonOECD in 2013 and the Trade (in US$) in United Arab Emirates in 2014?
Offer a very short reply. 3.44e+12. What is the difference between the Trade (in US$) in Lithuania in 2013 and the Trade (in US$) in Nepal in 2014?
Your answer should be very brief. 3.67e+1. What is the difference between the Trade (in US$) of Lithuania in 2013 and the Trade (in US$) of United Arab Emirates in 2014?
Provide a short and direct response. -3.52e+11. What is the difference between the Trade (in US$) in Nepal in 2013 and the Trade (in US$) in United Arab Emirates in 2014?
Offer a very short reply. -3.89e+11. What is the average Trade (in US$) of High income: nonOECD per year?
Provide a succinct answer. 3.19e+12. What is the average Trade (in US$) of Lithuania per year?
Your response must be concise. 2.96e+1. What is the average Trade (in US$) in Nepal per year?
Offer a terse response. 1.75e+09. What is the average Trade (in US$) of United Arab Emirates per year?
Provide a short and direct response. 2.92e+11. In the year 2007, what is the difference between the Trade (in US$) in High income: nonOECD and Trade (in US$) in Lithuania?
Offer a very short reply. 2.45e+12. In the year 2007, what is the difference between the Trade (in US$) of High income: nonOECD and Trade (in US$) of Nepal?
Your response must be concise. 2.47e+12. In the year 2007, what is the difference between the Trade (in US$) in High income: nonOECD and Trade (in US$) in United Arab Emirates?
Your response must be concise. 2.29e+12. In the year 2007, what is the difference between the Trade (in US$) of Lithuania and Trade (in US$) of Nepal?
Your response must be concise. 1.87e+1. In the year 2007, what is the difference between the Trade (in US$) of Lithuania and Trade (in US$) of United Arab Emirates?
Your answer should be compact. -1.67e+11. In the year 2007, what is the difference between the Trade (in US$) of Nepal and Trade (in US$) of United Arab Emirates?
Give a very brief answer. -1.85e+11. In the year 2008, what is the difference between the Trade (in US$) in High income: nonOECD and Trade (in US$) in Lithuania?
Offer a terse response. 2.95e+12. In the year 2008, what is the difference between the Trade (in US$) of High income: nonOECD and Trade (in US$) of Nepal?
Provide a succinct answer. 2.97e+12. In the year 2008, what is the difference between the Trade (in US$) in High income: nonOECD and Trade (in US$) in United Arab Emirates?
Offer a very short reply. 2.72e+12. In the year 2008, what is the difference between the Trade (in US$) in Lithuania and Trade (in US$) in Nepal?
Your answer should be compact. 2.57e+1. In the year 2008, what is the difference between the Trade (in US$) of Lithuania and Trade (in US$) of United Arab Emirates?
Make the answer very short. -2.21e+11. In the year 2008, what is the difference between the Trade (in US$) in Nepal and Trade (in US$) in United Arab Emirates?
Your response must be concise. -2.47e+11. In the year 2009, what is the difference between the Trade (in US$) of High income: nonOECD and Trade (in US$) of Lithuania?
Give a very brief answer. 2.26e+12. In the year 2009, what is the difference between the Trade (in US$) of High income: nonOECD and Trade (in US$) of Nepal?
Your answer should be compact. 2.27e+12. In the year 2009, what is the difference between the Trade (in US$) in High income: nonOECD and Trade (in US$) in United Arab Emirates?
Offer a very short reply. 2.07e+12. In the year 2009, what is the difference between the Trade (in US$) of Lithuania and Trade (in US$) of Nepal?
Ensure brevity in your answer.  1.78e+1. In the year 2009, what is the difference between the Trade (in US$) in Lithuania and Trade (in US$) in United Arab Emirates?
Your answer should be compact. -1.83e+11. In the year 2009, what is the difference between the Trade (in US$) of Nepal and Trade (in US$) of United Arab Emirates?
Keep it short and to the point. -2.00e+11. In the year 2010, what is the difference between the Trade (in US$) of High income: nonOECD and Trade (in US$) of Lithuania?
Make the answer very short. 2.87e+12. In the year 2010, what is the difference between the Trade (in US$) of High income: nonOECD and Trade (in US$) of Nepal?
Provide a short and direct response. 2.89e+12. In the year 2010, what is the difference between the Trade (in US$) of High income: nonOECD and Trade (in US$) of United Arab Emirates?
Give a very brief answer. 2.66e+12. In the year 2010, what is the difference between the Trade (in US$) of Lithuania and Trade (in US$) of Nepal?
Make the answer very short. 2.27e+1. In the year 2010, what is the difference between the Trade (in US$) of Lithuania and Trade (in US$) of United Arab Emirates?
Your answer should be compact. -2.01e+11. In the year 2010, what is the difference between the Trade (in US$) in Nepal and Trade (in US$) in United Arab Emirates?
Your response must be concise. -2.24e+11. In the year 2011, what is the difference between the Trade (in US$) of High income: nonOECD and Trade (in US$) of Lithuania?
Offer a terse response. 3.52e+12. In the year 2011, what is the difference between the Trade (in US$) of High income: nonOECD and Trade (in US$) of Nepal?
Your answer should be compact. 3.55e+12. In the year 2011, what is the difference between the Trade (in US$) in High income: nonOECD and Trade (in US$) in United Arab Emirates?
Offer a very short reply. 3.24e+12. In the year 2011, what is the difference between the Trade (in US$) in Lithuania and Trade (in US$) in Nepal?
Provide a short and direct response. 3.10e+1. In the year 2011, what is the difference between the Trade (in US$) of Lithuania and Trade (in US$) of United Arab Emirates?
Your answer should be very brief. -2.82e+11. In the year 2011, what is the difference between the Trade (in US$) of Nepal and Trade (in US$) of United Arab Emirates?
Ensure brevity in your answer.  -3.13e+11. In the year 2012, what is the difference between the Trade (in US$) of High income: nonOECD and Trade (in US$) of Lithuania?
Offer a very short reply. 3.72e+12. In the year 2012, what is the difference between the Trade (in US$) of High income: nonOECD and Trade (in US$) of Nepal?
Your response must be concise. 3.75e+12. In the year 2012, what is the difference between the Trade (in US$) in High income: nonOECD and Trade (in US$) in United Arab Emirates?
Ensure brevity in your answer.  3.37e+12. In the year 2012, what is the difference between the Trade (in US$) in Lithuania and Trade (in US$) in Nepal?
Keep it short and to the point. 3.31e+1. In the year 2012, what is the difference between the Trade (in US$) of Lithuania and Trade (in US$) of United Arab Emirates?
Ensure brevity in your answer.  -3.41e+11. In the year 2012, what is the difference between the Trade (in US$) of Nepal and Trade (in US$) of United Arab Emirates?
Make the answer very short. -3.74e+11. In the year 2013, what is the difference between the Trade (in US$) of High income: nonOECD and Trade (in US$) of Lithuania?
Ensure brevity in your answer.  3.79e+12. In the year 2013, what is the difference between the Trade (in US$) of High income: nonOECD and Trade (in US$) of Nepal?
Your answer should be very brief. 3.82e+12. In the year 2013, what is the difference between the Trade (in US$) of High income: nonOECD and Trade (in US$) of United Arab Emirates?
Ensure brevity in your answer.  3.43e+12. In the year 2013, what is the difference between the Trade (in US$) in Lithuania and Trade (in US$) in Nepal?
Provide a short and direct response. 3.70e+1. In the year 2013, what is the difference between the Trade (in US$) of Lithuania and Trade (in US$) of United Arab Emirates?
Provide a succinct answer. -3.53e+11. In the year 2013, what is the difference between the Trade (in US$) in Nepal and Trade (in US$) in United Arab Emirates?
Ensure brevity in your answer.  -3.90e+11. In the year 2014, what is the difference between the Trade (in US$) of High income: nonOECD and Trade (in US$) of Lithuania?
Your answer should be very brief. 3.71e+12. In the year 2014, what is the difference between the Trade (in US$) of High income: nonOECD and Trade (in US$) of Nepal?
Your answer should be very brief. 3.75e+12. In the year 2014, what is the difference between the Trade (in US$) in High income: nonOECD and Trade (in US$) in United Arab Emirates?
Make the answer very short. 3.36e+12. In the year 2014, what is the difference between the Trade (in US$) of Lithuania and Trade (in US$) of Nepal?
Offer a very short reply. 3.70e+1. In the year 2014, what is the difference between the Trade (in US$) of Lithuania and Trade (in US$) of United Arab Emirates?
Provide a succinct answer. -3.52e+11. In the year 2014, what is the difference between the Trade (in US$) in Nepal and Trade (in US$) in United Arab Emirates?
Your response must be concise. -3.89e+11. What is the ratio of the Trade (in US$) of High income: nonOECD in 2007 to that in 2008?
Your response must be concise. 0.83. What is the ratio of the Trade (in US$) in Lithuania in 2007 to that in 2008?
Keep it short and to the point. 0.73. What is the ratio of the Trade (in US$) in Nepal in 2007 to that in 2008?
Your response must be concise. 0.83. What is the ratio of the Trade (in US$) in United Arab Emirates in 2007 to that in 2008?
Keep it short and to the point. 0.75. What is the ratio of the Trade (in US$) in High income: nonOECD in 2007 to that in 2009?
Your answer should be very brief. 1.09. What is the ratio of the Trade (in US$) in Lithuania in 2007 to that in 2009?
Offer a very short reply. 1.03. What is the ratio of the Trade (in US$) of Nepal in 2007 to that in 2009?
Keep it short and to the point. 0.83. What is the ratio of the Trade (in US$) of United Arab Emirates in 2007 to that in 2009?
Give a very brief answer. 0.92. What is the ratio of the Trade (in US$) in High income: nonOECD in 2007 to that in 2010?
Offer a very short reply. 0.86. What is the ratio of the Trade (in US$) in Lithuania in 2007 to that in 2010?
Offer a very short reply. 0.83. What is the ratio of the Trade (in US$) of Nepal in 2007 to that in 2010?
Offer a terse response. 0.87. What is the ratio of the Trade (in US$) in United Arab Emirates in 2007 to that in 2010?
Your response must be concise. 0.83. What is the ratio of the Trade (in US$) in High income: nonOECD in 2007 to that in 2011?
Ensure brevity in your answer.  0.7. What is the ratio of the Trade (in US$) in Lithuania in 2007 to that in 2011?
Your response must be concise. 0.61. What is the ratio of the Trade (in US$) of Nepal in 2007 to that in 2011?
Offer a terse response. 0.79. What is the ratio of the Trade (in US$) of United Arab Emirates in 2007 to that in 2011?
Your answer should be compact. 0.59. What is the ratio of the Trade (in US$) of High income: nonOECD in 2007 to that in 2012?
Ensure brevity in your answer.  0.66. What is the ratio of the Trade (in US$) in Lithuania in 2007 to that in 2012?
Keep it short and to the point. 0.57. What is the ratio of the Trade (in US$) in Nepal in 2007 to that in 2012?
Offer a terse response. 0.7. What is the ratio of the Trade (in US$) in United Arab Emirates in 2007 to that in 2012?
Ensure brevity in your answer.  0.5. What is the ratio of the Trade (in US$) of High income: nonOECD in 2007 to that in 2013?
Your answer should be very brief. 0.65. What is the ratio of the Trade (in US$) of Lithuania in 2007 to that in 2013?
Your answer should be very brief. 0.51. What is the ratio of the Trade (in US$) of Nepal in 2007 to that in 2013?
Your answer should be very brief. 0.64. What is the ratio of the Trade (in US$) of United Arab Emirates in 2007 to that in 2013?
Keep it short and to the point. 0.48. What is the ratio of the Trade (in US$) of High income: nonOECD in 2007 to that in 2014?
Provide a succinct answer. 0.66. What is the ratio of the Trade (in US$) of Lithuania in 2007 to that in 2014?
Your answer should be very brief. 0.51. What is the ratio of the Trade (in US$) in Nepal in 2007 to that in 2014?
Your answer should be very brief. 0.58. What is the ratio of the Trade (in US$) in United Arab Emirates in 2007 to that in 2014?
Offer a terse response. 0.48. What is the ratio of the Trade (in US$) of High income: nonOECD in 2008 to that in 2009?
Your response must be concise. 1.31. What is the ratio of the Trade (in US$) in Lithuania in 2008 to that in 2009?
Ensure brevity in your answer.  1.41. What is the ratio of the Trade (in US$) of Nepal in 2008 to that in 2009?
Ensure brevity in your answer.  1. What is the ratio of the Trade (in US$) of United Arab Emirates in 2008 to that in 2009?
Your answer should be compact. 1.23. What is the ratio of the Trade (in US$) in High income: nonOECD in 2008 to that in 2010?
Your answer should be very brief. 1.03. What is the ratio of the Trade (in US$) of Lithuania in 2008 to that in 2010?
Your answer should be compact. 1.13. What is the ratio of the Trade (in US$) of Nepal in 2008 to that in 2010?
Offer a very short reply. 1.05. What is the ratio of the Trade (in US$) in United Arab Emirates in 2008 to that in 2010?
Offer a terse response. 1.1. What is the ratio of the Trade (in US$) of High income: nonOECD in 2008 to that in 2011?
Keep it short and to the point. 0.84. What is the ratio of the Trade (in US$) of Lithuania in 2008 to that in 2011?
Provide a succinct answer. 0.84. What is the ratio of the Trade (in US$) of Nepal in 2008 to that in 2011?
Provide a succinct answer. 0.95. What is the ratio of the Trade (in US$) in United Arab Emirates in 2008 to that in 2011?
Give a very brief answer. 0.79. What is the ratio of the Trade (in US$) of High income: nonOECD in 2008 to that in 2012?
Your response must be concise. 0.79. What is the ratio of the Trade (in US$) of Lithuania in 2008 to that in 2012?
Offer a very short reply. 0.78. What is the ratio of the Trade (in US$) of Nepal in 2008 to that in 2012?
Keep it short and to the point. 0.84. What is the ratio of the Trade (in US$) of United Arab Emirates in 2008 to that in 2012?
Provide a short and direct response. 0.66. What is the ratio of the Trade (in US$) of High income: nonOECD in 2008 to that in 2013?
Your answer should be compact. 0.78. What is the ratio of the Trade (in US$) in Lithuania in 2008 to that in 2013?
Provide a short and direct response. 0.7. What is the ratio of the Trade (in US$) of Nepal in 2008 to that in 2013?
Offer a terse response. 0.78. What is the ratio of the Trade (in US$) in United Arab Emirates in 2008 to that in 2013?
Your answer should be compact. 0.63. What is the ratio of the Trade (in US$) in High income: nonOECD in 2008 to that in 2014?
Your answer should be very brief. 0.79. What is the ratio of the Trade (in US$) in Lithuania in 2008 to that in 2014?
Ensure brevity in your answer.  0.7. What is the ratio of the Trade (in US$) in Nepal in 2008 to that in 2014?
Keep it short and to the point. 0.7. What is the ratio of the Trade (in US$) of United Arab Emirates in 2008 to that in 2014?
Give a very brief answer. 0.64. What is the ratio of the Trade (in US$) in High income: nonOECD in 2009 to that in 2010?
Keep it short and to the point. 0.79. What is the ratio of the Trade (in US$) in Lithuania in 2009 to that in 2010?
Your answer should be compact. 0.8. What is the ratio of the Trade (in US$) in Nepal in 2009 to that in 2010?
Offer a very short reply. 1.04. What is the ratio of the Trade (in US$) in United Arab Emirates in 2009 to that in 2010?
Offer a very short reply. 0.9. What is the ratio of the Trade (in US$) of High income: nonOECD in 2009 to that in 2011?
Offer a terse response. 0.64. What is the ratio of the Trade (in US$) in Lithuania in 2009 to that in 2011?
Your response must be concise. 0.6. What is the ratio of the Trade (in US$) in Nepal in 2009 to that in 2011?
Keep it short and to the point. 0.95. What is the ratio of the Trade (in US$) in United Arab Emirates in 2009 to that in 2011?
Offer a very short reply. 0.64. What is the ratio of the Trade (in US$) in High income: nonOECD in 2009 to that in 2012?
Ensure brevity in your answer.  0.61. What is the ratio of the Trade (in US$) in Lithuania in 2009 to that in 2012?
Offer a terse response. 0.56. What is the ratio of the Trade (in US$) in Nepal in 2009 to that in 2012?
Make the answer very short. 0.84. What is the ratio of the Trade (in US$) of United Arab Emirates in 2009 to that in 2012?
Your answer should be very brief. 0.54. What is the ratio of the Trade (in US$) in High income: nonOECD in 2009 to that in 2013?
Your answer should be compact. 0.59. What is the ratio of the Trade (in US$) in Lithuania in 2009 to that in 2013?
Your response must be concise. 0.5. What is the ratio of the Trade (in US$) in Nepal in 2009 to that in 2013?
Your answer should be compact. 0.78. What is the ratio of the Trade (in US$) in United Arab Emirates in 2009 to that in 2013?
Give a very brief answer. 0.51. What is the ratio of the Trade (in US$) of High income: nonOECD in 2009 to that in 2014?
Keep it short and to the point. 0.61. What is the ratio of the Trade (in US$) of Lithuania in 2009 to that in 2014?
Provide a short and direct response. 0.5. What is the ratio of the Trade (in US$) in Nepal in 2009 to that in 2014?
Ensure brevity in your answer.  0.69. What is the ratio of the Trade (in US$) of United Arab Emirates in 2009 to that in 2014?
Give a very brief answer. 0.52. What is the ratio of the Trade (in US$) of High income: nonOECD in 2010 to that in 2011?
Your response must be concise. 0.81. What is the ratio of the Trade (in US$) of Lithuania in 2010 to that in 2011?
Make the answer very short. 0.74. What is the ratio of the Trade (in US$) of Nepal in 2010 to that in 2011?
Ensure brevity in your answer.  0.91. What is the ratio of the Trade (in US$) of United Arab Emirates in 2010 to that in 2011?
Make the answer very short. 0.72. What is the ratio of the Trade (in US$) of High income: nonOECD in 2010 to that in 2012?
Your answer should be compact. 0.77. What is the ratio of the Trade (in US$) of Lithuania in 2010 to that in 2012?
Your response must be concise. 0.69. What is the ratio of the Trade (in US$) of Nepal in 2010 to that in 2012?
Your response must be concise. 0.81. What is the ratio of the Trade (in US$) of United Arab Emirates in 2010 to that in 2012?
Provide a short and direct response. 0.6. What is the ratio of the Trade (in US$) in High income: nonOECD in 2010 to that in 2013?
Provide a short and direct response. 0.76. What is the ratio of the Trade (in US$) of Lithuania in 2010 to that in 2013?
Offer a terse response. 0.62. What is the ratio of the Trade (in US$) in Nepal in 2010 to that in 2013?
Keep it short and to the point. 0.74. What is the ratio of the Trade (in US$) in United Arab Emirates in 2010 to that in 2013?
Offer a terse response. 0.57. What is the ratio of the Trade (in US$) of High income: nonOECD in 2010 to that in 2014?
Offer a terse response. 0.77. What is the ratio of the Trade (in US$) of Lithuania in 2010 to that in 2014?
Your answer should be very brief. 0.62. What is the ratio of the Trade (in US$) in Nepal in 2010 to that in 2014?
Offer a very short reply. 0.67. What is the ratio of the Trade (in US$) of United Arab Emirates in 2010 to that in 2014?
Provide a short and direct response. 0.58. What is the ratio of the Trade (in US$) in High income: nonOECD in 2011 to that in 2012?
Give a very brief answer. 0.95. What is the ratio of the Trade (in US$) of Lithuania in 2011 to that in 2012?
Keep it short and to the point. 0.93. What is the ratio of the Trade (in US$) of Nepal in 2011 to that in 2012?
Make the answer very short. 0.89. What is the ratio of the Trade (in US$) of United Arab Emirates in 2011 to that in 2012?
Offer a terse response. 0.84. What is the ratio of the Trade (in US$) of High income: nonOECD in 2011 to that in 2013?
Your answer should be compact. 0.93. What is the ratio of the Trade (in US$) in Lithuania in 2011 to that in 2013?
Make the answer very short. 0.84. What is the ratio of the Trade (in US$) in Nepal in 2011 to that in 2013?
Your answer should be very brief. 0.82. What is the ratio of the Trade (in US$) of United Arab Emirates in 2011 to that in 2013?
Your answer should be very brief. 0.8. What is the ratio of the Trade (in US$) in High income: nonOECD in 2011 to that in 2014?
Provide a short and direct response. 0.95. What is the ratio of the Trade (in US$) in Lithuania in 2011 to that in 2014?
Provide a succinct answer. 0.83. What is the ratio of the Trade (in US$) of Nepal in 2011 to that in 2014?
Your response must be concise. 0.73. What is the ratio of the Trade (in US$) of United Arab Emirates in 2011 to that in 2014?
Your answer should be compact. 0.8. What is the ratio of the Trade (in US$) of Lithuania in 2012 to that in 2013?
Provide a succinct answer. 0.9. What is the ratio of the Trade (in US$) of Nepal in 2012 to that in 2013?
Offer a terse response. 0.92. What is the ratio of the Trade (in US$) of United Arab Emirates in 2012 to that in 2013?
Your response must be concise. 0.96. What is the ratio of the Trade (in US$) in Lithuania in 2012 to that in 2014?
Make the answer very short. 0.89. What is the ratio of the Trade (in US$) of Nepal in 2012 to that in 2014?
Keep it short and to the point. 0.83. What is the ratio of the Trade (in US$) of United Arab Emirates in 2012 to that in 2014?
Your answer should be compact. 0.96. What is the ratio of the Trade (in US$) in High income: nonOECD in 2013 to that in 2014?
Offer a terse response. 1.02. What is the ratio of the Trade (in US$) of Nepal in 2013 to that in 2014?
Make the answer very short. 0.9. What is the difference between the highest and the second highest Trade (in US$) of High income: nonOECD?
Your response must be concise. 7.64e+1. What is the difference between the highest and the second highest Trade (in US$) in Lithuania?
Provide a succinct answer. 2.60e+08. What is the difference between the highest and the second highest Trade (in US$) of Nepal?
Your response must be concise. 2.41e+08. What is the difference between the highest and the second highest Trade (in US$) in United Arab Emirates?
Your response must be concise. 1.09e+09. What is the difference between the highest and the lowest Trade (in US$) of High income: nonOECD?
Your answer should be very brief. 1.55e+12. What is the difference between the highest and the lowest Trade (in US$) of Lithuania?
Offer a terse response. 1.98e+1. What is the difference between the highest and the lowest Trade (in US$) in Nepal?
Offer a terse response. 9.74e+08. What is the difference between the highest and the lowest Trade (in US$) of United Arab Emirates?
Give a very brief answer. 2.06e+11. 